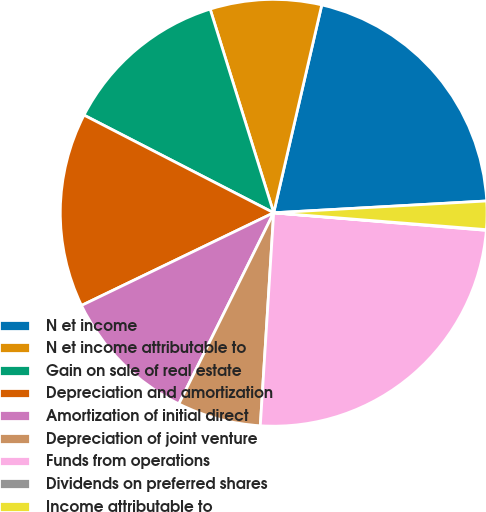Convert chart to OTSL. <chart><loc_0><loc_0><loc_500><loc_500><pie_chart><fcel>N et income<fcel>N et income attributable to<fcel>Gain on sale of real estate<fcel>Depreciation and amortization<fcel>Amortization of initial direct<fcel>Depreciation of joint venture<fcel>Funds from operations<fcel>Dividends on preferred shares<fcel>Income attributable to<nl><fcel>20.5%<fcel>8.43%<fcel>12.62%<fcel>14.72%<fcel>10.52%<fcel>6.33%<fcel>24.69%<fcel>0.05%<fcel>2.14%<nl></chart> 